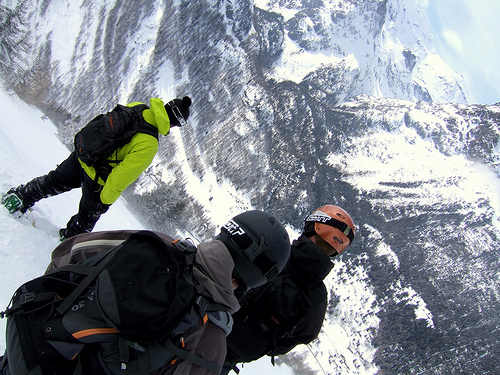<image>
Is the man behind the pack? No. The man is not behind the pack. From this viewpoint, the man appears to be positioned elsewhere in the scene. 